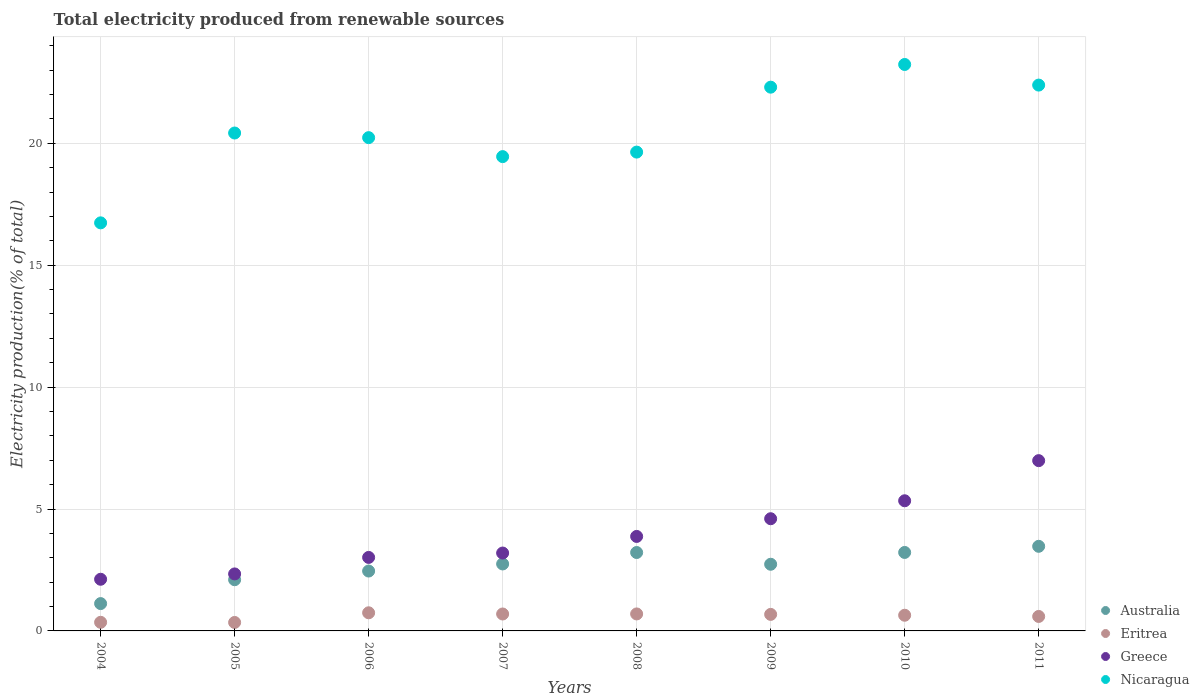Is the number of dotlines equal to the number of legend labels?
Your response must be concise. Yes. What is the total electricity produced in Nicaragua in 2004?
Provide a succinct answer. 16.74. Across all years, what is the maximum total electricity produced in Greece?
Give a very brief answer. 6.98. Across all years, what is the minimum total electricity produced in Greece?
Ensure brevity in your answer.  2.12. In which year was the total electricity produced in Australia minimum?
Provide a short and direct response. 2004. What is the total total electricity produced in Eritrea in the graph?
Ensure brevity in your answer.  4.75. What is the difference between the total electricity produced in Greece in 2006 and that in 2010?
Your answer should be very brief. -2.32. What is the difference between the total electricity produced in Australia in 2006 and the total electricity produced in Greece in 2005?
Give a very brief answer. 0.12. What is the average total electricity produced in Eritrea per year?
Offer a very short reply. 0.59. In the year 2010, what is the difference between the total electricity produced in Eritrea and total electricity produced in Greece?
Your answer should be compact. -4.69. In how many years, is the total electricity produced in Australia greater than 9 %?
Give a very brief answer. 0. What is the ratio of the total electricity produced in Greece in 2005 to that in 2006?
Make the answer very short. 0.78. What is the difference between the highest and the second highest total electricity produced in Australia?
Your answer should be compact. 0.25. What is the difference between the highest and the lowest total electricity produced in Eritrea?
Your answer should be very brief. 0.4. Is it the case that in every year, the sum of the total electricity produced in Nicaragua and total electricity produced in Eritrea  is greater than the total electricity produced in Australia?
Your answer should be very brief. Yes. Does the total electricity produced in Australia monotonically increase over the years?
Provide a short and direct response. No. How many dotlines are there?
Provide a succinct answer. 4. Does the graph contain any zero values?
Your response must be concise. No. How are the legend labels stacked?
Your response must be concise. Vertical. What is the title of the graph?
Your answer should be compact. Total electricity produced from renewable sources. What is the label or title of the Y-axis?
Provide a succinct answer. Electricity production(% of total). What is the Electricity production(% of total) in Australia in 2004?
Offer a terse response. 1.12. What is the Electricity production(% of total) in Eritrea in 2004?
Offer a terse response. 0.35. What is the Electricity production(% of total) of Greece in 2004?
Ensure brevity in your answer.  2.12. What is the Electricity production(% of total) in Nicaragua in 2004?
Provide a succinct answer. 16.74. What is the Electricity production(% of total) of Australia in 2005?
Keep it short and to the point. 2.1. What is the Electricity production(% of total) of Eritrea in 2005?
Offer a very short reply. 0.35. What is the Electricity production(% of total) of Greece in 2005?
Offer a terse response. 2.34. What is the Electricity production(% of total) in Nicaragua in 2005?
Your answer should be very brief. 20.42. What is the Electricity production(% of total) of Australia in 2006?
Your answer should be compact. 2.46. What is the Electricity production(% of total) of Eritrea in 2006?
Keep it short and to the point. 0.74. What is the Electricity production(% of total) of Greece in 2006?
Provide a short and direct response. 3.01. What is the Electricity production(% of total) in Nicaragua in 2006?
Offer a very short reply. 20.23. What is the Electricity production(% of total) of Australia in 2007?
Ensure brevity in your answer.  2.75. What is the Electricity production(% of total) of Eritrea in 2007?
Your answer should be very brief. 0.69. What is the Electricity production(% of total) of Greece in 2007?
Provide a succinct answer. 3.19. What is the Electricity production(% of total) in Nicaragua in 2007?
Provide a succinct answer. 19.45. What is the Electricity production(% of total) in Australia in 2008?
Offer a terse response. 3.22. What is the Electricity production(% of total) of Eritrea in 2008?
Provide a short and direct response. 0.7. What is the Electricity production(% of total) of Greece in 2008?
Ensure brevity in your answer.  3.88. What is the Electricity production(% of total) in Nicaragua in 2008?
Make the answer very short. 19.64. What is the Electricity production(% of total) of Australia in 2009?
Offer a very short reply. 2.73. What is the Electricity production(% of total) of Eritrea in 2009?
Give a very brief answer. 0.68. What is the Electricity production(% of total) in Greece in 2009?
Ensure brevity in your answer.  4.6. What is the Electricity production(% of total) in Nicaragua in 2009?
Make the answer very short. 22.3. What is the Electricity production(% of total) of Australia in 2010?
Make the answer very short. 3.22. What is the Electricity production(% of total) of Eritrea in 2010?
Your response must be concise. 0.64. What is the Electricity production(% of total) in Greece in 2010?
Give a very brief answer. 5.34. What is the Electricity production(% of total) of Nicaragua in 2010?
Offer a terse response. 23.23. What is the Electricity production(% of total) in Australia in 2011?
Provide a succinct answer. 3.47. What is the Electricity production(% of total) of Eritrea in 2011?
Offer a very short reply. 0.59. What is the Electricity production(% of total) of Greece in 2011?
Your answer should be very brief. 6.98. What is the Electricity production(% of total) in Nicaragua in 2011?
Offer a terse response. 22.38. Across all years, what is the maximum Electricity production(% of total) of Australia?
Provide a succinct answer. 3.47. Across all years, what is the maximum Electricity production(% of total) in Eritrea?
Your answer should be compact. 0.74. Across all years, what is the maximum Electricity production(% of total) in Greece?
Your response must be concise. 6.98. Across all years, what is the maximum Electricity production(% of total) of Nicaragua?
Provide a succinct answer. 23.23. Across all years, what is the minimum Electricity production(% of total) in Australia?
Keep it short and to the point. 1.12. Across all years, what is the minimum Electricity production(% of total) in Eritrea?
Your response must be concise. 0.35. Across all years, what is the minimum Electricity production(% of total) in Greece?
Give a very brief answer. 2.12. Across all years, what is the minimum Electricity production(% of total) in Nicaragua?
Make the answer very short. 16.74. What is the total Electricity production(% of total) of Australia in the graph?
Offer a terse response. 21.06. What is the total Electricity production(% of total) of Eritrea in the graph?
Make the answer very short. 4.75. What is the total Electricity production(% of total) in Greece in the graph?
Provide a short and direct response. 31.46. What is the total Electricity production(% of total) of Nicaragua in the graph?
Make the answer very short. 164.39. What is the difference between the Electricity production(% of total) of Australia in 2004 and that in 2005?
Your response must be concise. -0.98. What is the difference between the Electricity production(% of total) of Eritrea in 2004 and that in 2005?
Make the answer very short. 0.01. What is the difference between the Electricity production(% of total) in Greece in 2004 and that in 2005?
Your response must be concise. -0.22. What is the difference between the Electricity production(% of total) of Nicaragua in 2004 and that in 2005?
Provide a short and direct response. -3.68. What is the difference between the Electricity production(% of total) in Australia in 2004 and that in 2006?
Your answer should be very brief. -1.33. What is the difference between the Electricity production(% of total) of Eritrea in 2004 and that in 2006?
Your answer should be very brief. -0.39. What is the difference between the Electricity production(% of total) of Greece in 2004 and that in 2006?
Your response must be concise. -0.9. What is the difference between the Electricity production(% of total) in Nicaragua in 2004 and that in 2006?
Provide a succinct answer. -3.49. What is the difference between the Electricity production(% of total) of Australia in 2004 and that in 2007?
Offer a terse response. -1.63. What is the difference between the Electricity production(% of total) of Eritrea in 2004 and that in 2007?
Give a very brief answer. -0.34. What is the difference between the Electricity production(% of total) of Greece in 2004 and that in 2007?
Give a very brief answer. -1.08. What is the difference between the Electricity production(% of total) in Nicaragua in 2004 and that in 2007?
Offer a terse response. -2.72. What is the difference between the Electricity production(% of total) of Australia in 2004 and that in 2008?
Keep it short and to the point. -2.09. What is the difference between the Electricity production(% of total) of Eritrea in 2004 and that in 2008?
Your response must be concise. -0.34. What is the difference between the Electricity production(% of total) of Greece in 2004 and that in 2008?
Give a very brief answer. -1.76. What is the difference between the Electricity production(% of total) in Nicaragua in 2004 and that in 2008?
Offer a terse response. -2.9. What is the difference between the Electricity production(% of total) in Australia in 2004 and that in 2009?
Make the answer very short. -1.61. What is the difference between the Electricity production(% of total) in Eritrea in 2004 and that in 2009?
Keep it short and to the point. -0.32. What is the difference between the Electricity production(% of total) in Greece in 2004 and that in 2009?
Your answer should be compact. -2.48. What is the difference between the Electricity production(% of total) in Nicaragua in 2004 and that in 2009?
Your answer should be very brief. -5.56. What is the difference between the Electricity production(% of total) in Australia in 2004 and that in 2010?
Offer a terse response. -2.1. What is the difference between the Electricity production(% of total) in Eritrea in 2004 and that in 2010?
Provide a short and direct response. -0.29. What is the difference between the Electricity production(% of total) in Greece in 2004 and that in 2010?
Keep it short and to the point. -3.22. What is the difference between the Electricity production(% of total) in Nicaragua in 2004 and that in 2010?
Offer a terse response. -6.5. What is the difference between the Electricity production(% of total) in Australia in 2004 and that in 2011?
Provide a succinct answer. -2.35. What is the difference between the Electricity production(% of total) in Eritrea in 2004 and that in 2011?
Your answer should be very brief. -0.24. What is the difference between the Electricity production(% of total) of Greece in 2004 and that in 2011?
Offer a terse response. -4.86. What is the difference between the Electricity production(% of total) of Nicaragua in 2004 and that in 2011?
Keep it short and to the point. -5.65. What is the difference between the Electricity production(% of total) in Australia in 2005 and that in 2006?
Your answer should be compact. -0.36. What is the difference between the Electricity production(% of total) in Eritrea in 2005 and that in 2006?
Make the answer very short. -0.4. What is the difference between the Electricity production(% of total) of Greece in 2005 and that in 2006?
Offer a very short reply. -0.68. What is the difference between the Electricity production(% of total) in Nicaragua in 2005 and that in 2006?
Provide a short and direct response. 0.19. What is the difference between the Electricity production(% of total) of Australia in 2005 and that in 2007?
Provide a short and direct response. -0.65. What is the difference between the Electricity production(% of total) of Eritrea in 2005 and that in 2007?
Give a very brief answer. -0.35. What is the difference between the Electricity production(% of total) in Greece in 2005 and that in 2007?
Your answer should be very brief. -0.86. What is the difference between the Electricity production(% of total) of Nicaragua in 2005 and that in 2007?
Make the answer very short. 0.97. What is the difference between the Electricity production(% of total) in Australia in 2005 and that in 2008?
Offer a terse response. -1.12. What is the difference between the Electricity production(% of total) of Eritrea in 2005 and that in 2008?
Provide a short and direct response. -0.35. What is the difference between the Electricity production(% of total) in Greece in 2005 and that in 2008?
Provide a succinct answer. -1.54. What is the difference between the Electricity production(% of total) in Nicaragua in 2005 and that in 2008?
Provide a succinct answer. 0.78. What is the difference between the Electricity production(% of total) in Australia in 2005 and that in 2009?
Give a very brief answer. -0.63. What is the difference between the Electricity production(% of total) of Eritrea in 2005 and that in 2009?
Provide a short and direct response. -0.33. What is the difference between the Electricity production(% of total) in Greece in 2005 and that in 2009?
Your answer should be compact. -2.26. What is the difference between the Electricity production(% of total) in Nicaragua in 2005 and that in 2009?
Ensure brevity in your answer.  -1.88. What is the difference between the Electricity production(% of total) in Australia in 2005 and that in 2010?
Offer a terse response. -1.12. What is the difference between the Electricity production(% of total) in Eritrea in 2005 and that in 2010?
Make the answer very short. -0.3. What is the difference between the Electricity production(% of total) of Greece in 2005 and that in 2010?
Your response must be concise. -3. What is the difference between the Electricity production(% of total) of Nicaragua in 2005 and that in 2010?
Your response must be concise. -2.81. What is the difference between the Electricity production(% of total) in Australia in 2005 and that in 2011?
Make the answer very short. -1.37. What is the difference between the Electricity production(% of total) in Eritrea in 2005 and that in 2011?
Your response must be concise. -0.25. What is the difference between the Electricity production(% of total) of Greece in 2005 and that in 2011?
Your response must be concise. -4.65. What is the difference between the Electricity production(% of total) of Nicaragua in 2005 and that in 2011?
Make the answer very short. -1.97. What is the difference between the Electricity production(% of total) in Australia in 2006 and that in 2007?
Make the answer very short. -0.29. What is the difference between the Electricity production(% of total) of Eritrea in 2006 and that in 2007?
Keep it short and to the point. 0.05. What is the difference between the Electricity production(% of total) in Greece in 2006 and that in 2007?
Make the answer very short. -0.18. What is the difference between the Electricity production(% of total) of Nicaragua in 2006 and that in 2007?
Your answer should be compact. 0.78. What is the difference between the Electricity production(% of total) in Australia in 2006 and that in 2008?
Offer a very short reply. -0.76. What is the difference between the Electricity production(% of total) of Eritrea in 2006 and that in 2008?
Make the answer very short. 0.05. What is the difference between the Electricity production(% of total) in Greece in 2006 and that in 2008?
Your answer should be very brief. -0.86. What is the difference between the Electricity production(% of total) of Nicaragua in 2006 and that in 2008?
Offer a very short reply. 0.59. What is the difference between the Electricity production(% of total) in Australia in 2006 and that in 2009?
Make the answer very short. -0.28. What is the difference between the Electricity production(% of total) of Eritrea in 2006 and that in 2009?
Keep it short and to the point. 0.07. What is the difference between the Electricity production(% of total) of Greece in 2006 and that in 2009?
Make the answer very short. -1.59. What is the difference between the Electricity production(% of total) in Nicaragua in 2006 and that in 2009?
Make the answer very short. -2.07. What is the difference between the Electricity production(% of total) of Australia in 2006 and that in 2010?
Keep it short and to the point. -0.76. What is the difference between the Electricity production(% of total) of Eritrea in 2006 and that in 2010?
Make the answer very short. 0.1. What is the difference between the Electricity production(% of total) of Greece in 2006 and that in 2010?
Provide a succinct answer. -2.32. What is the difference between the Electricity production(% of total) in Nicaragua in 2006 and that in 2010?
Give a very brief answer. -3. What is the difference between the Electricity production(% of total) in Australia in 2006 and that in 2011?
Your answer should be very brief. -1.01. What is the difference between the Electricity production(% of total) in Eritrea in 2006 and that in 2011?
Offer a terse response. 0.15. What is the difference between the Electricity production(% of total) in Greece in 2006 and that in 2011?
Your answer should be compact. -3.97. What is the difference between the Electricity production(% of total) of Nicaragua in 2006 and that in 2011?
Your answer should be very brief. -2.16. What is the difference between the Electricity production(% of total) in Australia in 2007 and that in 2008?
Your answer should be very brief. -0.47. What is the difference between the Electricity production(% of total) of Eritrea in 2007 and that in 2008?
Your answer should be compact. -0. What is the difference between the Electricity production(% of total) of Greece in 2007 and that in 2008?
Offer a very short reply. -0.68. What is the difference between the Electricity production(% of total) in Nicaragua in 2007 and that in 2008?
Your answer should be compact. -0.19. What is the difference between the Electricity production(% of total) in Australia in 2007 and that in 2009?
Provide a short and direct response. 0.01. What is the difference between the Electricity production(% of total) of Eritrea in 2007 and that in 2009?
Give a very brief answer. 0.02. What is the difference between the Electricity production(% of total) in Greece in 2007 and that in 2009?
Provide a succinct answer. -1.41. What is the difference between the Electricity production(% of total) of Nicaragua in 2007 and that in 2009?
Your answer should be very brief. -2.85. What is the difference between the Electricity production(% of total) of Australia in 2007 and that in 2010?
Your response must be concise. -0.47. What is the difference between the Electricity production(% of total) of Eritrea in 2007 and that in 2010?
Provide a short and direct response. 0.05. What is the difference between the Electricity production(% of total) in Greece in 2007 and that in 2010?
Provide a succinct answer. -2.14. What is the difference between the Electricity production(% of total) in Nicaragua in 2007 and that in 2010?
Provide a short and direct response. -3.78. What is the difference between the Electricity production(% of total) of Australia in 2007 and that in 2011?
Give a very brief answer. -0.72. What is the difference between the Electricity production(% of total) in Eritrea in 2007 and that in 2011?
Offer a very short reply. 0.1. What is the difference between the Electricity production(% of total) in Greece in 2007 and that in 2011?
Ensure brevity in your answer.  -3.79. What is the difference between the Electricity production(% of total) of Nicaragua in 2007 and that in 2011?
Give a very brief answer. -2.93. What is the difference between the Electricity production(% of total) in Australia in 2008 and that in 2009?
Offer a very short reply. 0.48. What is the difference between the Electricity production(% of total) of Eritrea in 2008 and that in 2009?
Your answer should be compact. 0.02. What is the difference between the Electricity production(% of total) of Greece in 2008 and that in 2009?
Provide a short and direct response. -0.73. What is the difference between the Electricity production(% of total) of Nicaragua in 2008 and that in 2009?
Offer a terse response. -2.66. What is the difference between the Electricity production(% of total) in Australia in 2008 and that in 2010?
Ensure brevity in your answer.  -0. What is the difference between the Electricity production(% of total) of Eritrea in 2008 and that in 2010?
Your answer should be very brief. 0.05. What is the difference between the Electricity production(% of total) in Greece in 2008 and that in 2010?
Your response must be concise. -1.46. What is the difference between the Electricity production(% of total) in Nicaragua in 2008 and that in 2010?
Your answer should be compact. -3.59. What is the difference between the Electricity production(% of total) in Australia in 2008 and that in 2011?
Ensure brevity in your answer.  -0.25. What is the difference between the Electricity production(% of total) in Eritrea in 2008 and that in 2011?
Make the answer very short. 0.1. What is the difference between the Electricity production(% of total) of Greece in 2008 and that in 2011?
Your answer should be compact. -3.11. What is the difference between the Electricity production(% of total) in Nicaragua in 2008 and that in 2011?
Ensure brevity in your answer.  -2.75. What is the difference between the Electricity production(% of total) in Australia in 2009 and that in 2010?
Give a very brief answer. -0.48. What is the difference between the Electricity production(% of total) in Eritrea in 2009 and that in 2010?
Keep it short and to the point. 0.03. What is the difference between the Electricity production(% of total) in Greece in 2009 and that in 2010?
Ensure brevity in your answer.  -0.74. What is the difference between the Electricity production(% of total) of Nicaragua in 2009 and that in 2010?
Keep it short and to the point. -0.93. What is the difference between the Electricity production(% of total) of Australia in 2009 and that in 2011?
Your answer should be very brief. -0.74. What is the difference between the Electricity production(% of total) in Eritrea in 2009 and that in 2011?
Keep it short and to the point. 0.08. What is the difference between the Electricity production(% of total) of Greece in 2009 and that in 2011?
Ensure brevity in your answer.  -2.38. What is the difference between the Electricity production(% of total) in Nicaragua in 2009 and that in 2011?
Give a very brief answer. -0.09. What is the difference between the Electricity production(% of total) in Australia in 2010 and that in 2011?
Provide a short and direct response. -0.25. What is the difference between the Electricity production(% of total) in Eritrea in 2010 and that in 2011?
Give a very brief answer. 0.05. What is the difference between the Electricity production(% of total) of Greece in 2010 and that in 2011?
Your answer should be very brief. -1.65. What is the difference between the Electricity production(% of total) of Nicaragua in 2010 and that in 2011?
Provide a short and direct response. 0.85. What is the difference between the Electricity production(% of total) of Australia in 2004 and the Electricity production(% of total) of Eritrea in 2005?
Offer a terse response. 0.77. What is the difference between the Electricity production(% of total) in Australia in 2004 and the Electricity production(% of total) in Greece in 2005?
Provide a succinct answer. -1.22. What is the difference between the Electricity production(% of total) of Australia in 2004 and the Electricity production(% of total) of Nicaragua in 2005?
Give a very brief answer. -19.3. What is the difference between the Electricity production(% of total) in Eritrea in 2004 and the Electricity production(% of total) in Greece in 2005?
Your answer should be very brief. -1.98. What is the difference between the Electricity production(% of total) in Eritrea in 2004 and the Electricity production(% of total) in Nicaragua in 2005?
Your answer should be compact. -20.07. What is the difference between the Electricity production(% of total) in Greece in 2004 and the Electricity production(% of total) in Nicaragua in 2005?
Offer a terse response. -18.3. What is the difference between the Electricity production(% of total) in Australia in 2004 and the Electricity production(% of total) in Eritrea in 2006?
Ensure brevity in your answer.  0.38. What is the difference between the Electricity production(% of total) in Australia in 2004 and the Electricity production(% of total) in Greece in 2006?
Your answer should be compact. -1.89. What is the difference between the Electricity production(% of total) of Australia in 2004 and the Electricity production(% of total) of Nicaragua in 2006?
Your answer should be compact. -19.11. What is the difference between the Electricity production(% of total) of Eritrea in 2004 and the Electricity production(% of total) of Greece in 2006?
Your answer should be compact. -2.66. What is the difference between the Electricity production(% of total) in Eritrea in 2004 and the Electricity production(% of total) in Nicaragua in 2006?
Ensure brevity in your answer.  -19.88. What is the difference between the Electricity production(% of total) in Greece in 2004 and the Electricity production(% of total) in Nicaragua in 2006?
Your response must be concise. -18.11. What is the difference between the Electricity production(% of total) in Australia in 2004 and the Electricity production(% of total) in Eritrea in 2007?
Offer a very short reply. 0.43. What is the difference between the Electricity production(% of total) in Australia in 2004 and the Electricity production(% of total) in Greece in 2007?
Keep it short and to the point. -2.07. What is the difference between the Electricity production(% of total) of Australia in 2004 and the Electricity production(% of total) of Nicaragua in 2007?
Your answer should be very brief. -18.33. What is the difference between the Electricity production(% of total) in Eritrea in 2004 and the Electricity production(% of total) in Greece in 2007?
Offer a very short reply. -2.84. What is the difference between the Electricity production(% of total) in Eritrea in 2004 and the Electricity production(% of total) in Nicaragua in 2007?
Ensure brevity in your answer.  -19.1. What is the difference between the Electricity production(% of total) of Greece in 2004 and the Electricity production(% of total) of Nicaragua in 2007?
Provide a succinct answer. -17.33. What is the difference between the Electricity production(% of total) of Australia in 2004 and the Electricity production(% of total) of Eritrea in 2008?
Your response must be concise. 0.42. What is the difference between the Electricity production(% of total) in Australia in 2004 and the Electricity production(% of total) in Greece in 2008?
Your answer should be compact. -2.75. What is the difference between the Electricity production(% of total) in Australia in 2004 and the Electricity production(% of total) in Nicaragua in 2008?
Provide a succinct answer. -18.52. What is the difference between the Electricity production(% of total) in Eritrea in 2004 and the Electricity production(% of total) in Greece in 2008?
Give a very brief answer. -3.52. What is the difference between the Electricity production(% of total) of Eritrea in 2004 and the Electricity production(% of total) of Nicaragua in 2008?
Give a very brief answer. -19.28. What is the difference between the Electricity production(% of total) of Greece in 2004 and the Electricity production(% of total) of Nicaragua in 2008?
Keep it short and to the point. -17.52. What is the difference between the Electricity production(% of total) of Australia in 2004 and the Electricity production(% of total) of Eritrea in 2009?
Provide a short and direct response. 0.44. What is the difference between the Electricity production(% of total) in Australia in 2004 and the Electricity production(% of total) in Greece in 2009?
Offer a terse response. -3.48. What is the difference between the Electricity production(% of total) of Australia in 2004 and the Electricity production(% of total) of Nicaragua in 2009?
Your response must be concise. -21.18. What is the difference between the Electricity production(% of total) in Eritrea in 2004 and the Electricity production(% of total) in Greece in 2009?
Make the answer very short. -4.25. What is the difference between the Electricity production(% of total) of Eritrea in 2004 and the Electricity production(% of total) of Nicaragua in 2009?
Keep it short and to the point. -21.95. What is the difference between the Electricity production(% of total) of Greece in 2004 and the Electricity production(% of total) of Nicaragua in 2009?
Ensure brevity in your answer.  -20.18. What is the difference between the Electricity production(% of total) of Australia in 2004 and the Electricity production(% of total) of Eritrea in 2010?
Your response must be concise. 0.48. What is the difference between the Electricity production(% of total) of Australia in 2004 and the Electricity production(% of total) of Greece in 2010?
Ensure brevity in your answer.  -4.22. What is the difference between the Electricity production(% of total) in Australia in 2004 and the Electricity production(% of total) in Nicaragua in 2010?
Offer a terse response. -22.11. What is the difference between the Electricity production(% of total) of Eritrea in 2004 and the Electricity production(% of total) of Greece in 2010?
Keep it short and to the point. -4.98. What is the difference between the Electricity production(% of total) of Eritrea in 2004 and the Electricity production(% of total) of Nicaragua in 2010?
Provide a succinct answer. -22.88. What is the difference between the Electricity production(% of total) of Greece in 2004 and the Electricity production(% of total) of Nicaragua in 2010?
Make the answer very short. -21.11. What is the difference between the Electricity production(% of total) of Australia in 2004 and the Electricity production(% of total) of Eritrea in 2011?
Offer a very short reply. 0.53. What is the difference between the Electricity production(% of total) of Australia in 2004 and the Electricity production(% of total) of Greece in 2011?
Your answer should be very brief. -5.86. What is the difference between the Electricity production(% of total) in Australia in 2004 and the Electricity production(% of total) in Nicaragua in 2011?
Make the answer very short. -21.26. What is the difference between the Electricity production(% of total) of Eritrea in 2004 and the Electricity production(% of total) of Greece in 2011?
Provide a short and direct response. -6.63. What is the difference between the Electricity production(% of total) in Eritrea in 2004 and the Electricity production(% of total) in Nicaragua in 2011?
Give a very brief answer. -22.03. What is the difference between the Electricity production(% of total) of Greece in 2004 and the Electricity production(% of total) of Nicaragua in 2011?
Ensure brevity in your answer.  -20.27. What is the difference between the Electricity production(% of total) of Australia in 2005 and the Electricity production(% of total) of Eritrea in 2006?
Offer a terse response. 1.36. What is the difference between the Electricity production(% of total) in Australia in 2005 and the Electricity production(% of total) in Greece in 2006?
Give a very brief answer. -0.91. What is the difference between the Electricity production(% of total) of Australia in 2005 and the Electricity production(% of total) of Nicaragua in 2006?
Your response must be concise. -18.13. What is the difference between the Electricity production(% of total) in Eritrea in 2005 and the Electricity production(% of total) in Greece in 2006?
Provide a short and direct response. -2.67. What is the difference between the Electricity production(% of total) in Eritrea in 2005 and the Electricity production(% of total) in Nicaragua in 2006?
Your answer should be compact. -19.88. What is the difference between the Electricity production(% of total) of Greece in 2005 and the Electricity production(% of total) of Nicaragua in 2006?
Keep it short and to the point. -17.89. What is the difference between the Electricity production(% of total) in Australia in 2005 and the Electricity production(% of total) in Eritrea in 2007?
Ensure brevity in your answer.  1.41. What is the difference between the Electricity production(% of total) of Australia in 2005 and the Electricity production(% of total) of Greece in 2007?
Your answer should be compact. -1.09. What is the difference between the Electricity production(% of total) of Australia in 2005 and the Electricity production(% of total) of Nicaragua in 2007?
Your response must be concise. -17.35. What is the difference between the Electricity production(% of total) of Eritrea in 2005 and the Electricity production(% of total) of Greece in 2007?
Your answer should be very brief. -2.85. What is the difference between the Electricity production(% of total) in Eritrea in 2005 and the Electricity production(% of total) in Nicaragua in 2007?
Provide a succinct answer. -19.1. What is the difference between the Electricity production(% of total) in Greece in 2005 and the Electricity production(% of total) in Nicaragua in 2007?
Give a very brief answer. -17.11. What is the difference between the Electricity production(% of total) of Australia in 2005 and the Electricity production(% of total) of Eritrea in 2008?
Provide a short and direct response. 1.4. What is the difference between the Electricity production(% of total) of Australia in 2005 and the Electricity production(% of total) of Greece in 2008?
Offer a terse response. -1.78. What is the difference between the Electricity production(% of total) of Australia in 2005 and the Electricity production(% of total) of Nicaragua in 2008?
Make the answer very short. -17.54. What is the difference between the Electricity production(% of total) in Eritrea in 2005 and the Electricity production(% of total) in Greece in 2008?
Your answer should be very brief. -3.53. What is the difference between the Electricity production(% of total) of Eritrea in 2005 and the Electricity production(% of total) of Nicaragua in 2008?
Your response must be concise. -19.29. What is the difference between the Electricity production(% of total) in Greece in 2005 and the Electricity production(% of total) in Nicaragua in 2008?
Your answer should be very brief. -17.3. What is the difference between the Electricity production(% of total) in Australia in 2005 and the Electricity production(% of total) in Eritrea in 2009?
Keep it short and to the point. 1.42. What is the difference between the Electricity production(% of total) of Australia in 2005 and the Electricity production(% of total) of Greece in 2009?
Keep it short and to the point. -2.5. What is the difference between the Electricity production(% of total) of Australia in 2005 and the Electricity production(% of total) of Nicaragua in 2009?
Give a very brief answer. -20.2. What is the difference between the Electricity production(% of total) in Eritrea in 2005 and the Electricity production(% of total) in Greece in 2009?
Your answer should be very brief. -4.25. What is the difference between the Electricity production(% of total) in Eritrea in 2005 and the Electricity production(% of total) in Nicaragua in 2009?
Keep it short and to the point. -21.95. What is the difference between the Electricity production(% of total) of Greece in 2005 and the Electricity production(% of total) of Nicaragua in 2009?
Provide a succinct answer. -19.96. What is the difference between the Electricity production(% of total) in Australia in 2005 and the Electricity production(% of total) in Eritrea in 2010?
Provide a short and direct response. 1.46. What is the difference between the Electricity production(% of total) in Australia in 2005 and the Electricity production(% of total) in Greece in 2010?
Your response must be concise. -3.24. What is the difference between the Electricity production(% of total) in Australia in 2005 and the Electricity production(% of total) in Nicaragua in 2010?
Offer a very short reply. -21.13. What is the difference between the Electricity production(% of total) in Eritrea in 2005 and the Electricity production(% of total) in Greece in 2010?
Give a very brief answer. -4.99. What is the difference between the Electricity production(% of total) of Eritrea in 2005 and the Electricity production(% of total) of Nicaragua in 2010?
Give a very brief answer. -22.88. What is the difference between the Electricity production(% of total) in Greece in 2005 and the Electricity production(% of total) in Nicaragua in 2010?
Your answer should be very brief. -20.89. What is the difference between the Electricity production(% of total) in Australia in 2005 and the Electricity production(% of total) in Eritrea in 2011?
Your answer should be very brief. 1.51. What is the difference between the Electricity production(% of total) in Australia in 2005 and the Electricity production(% of total) in Greece in 2011?
Keep it short and to the point. -4.88. What is the difference between the Electricity production(% of total) in Australia in 2005 and the Electricity production(% of total) in Nicaragua in 2011?
Your answer should be compact. -20.29. What is the difference between the Electricity production(% of total) of Eritrea in 2005 and the Electricity production(% of total) of Greece in 2011?
Make the answer very short. -6.64. What is the difference between the Electricity production(% of total) of Eritrea in 2005 and the Electricity production(% of total) of Nicaragua in 2011?
Ensure brevity in your answer.  -22.04. What is the difference between the Electricity production(% of total) in Greece in 2005 and the Electricity production(% of total) in Nicaragua in 2011?
Your response must be concise. -20.05. What is the difference between the Electricity production(% of total) in Australia in 2006 and the Electricity production(% of total) in Eritrea in 2007?
Ensure brevity in your answer.  1.76. What is the difference between the Electricity production(% of total) in Australia in 2006 and the Electricity production(% of total) in Greece in 2007?
Give a very brief answer. -0.74. What is the difference between the Electricity production(% of total) in Australia in 2006 and the Electricity production(% of total) in Nicaragua in 2007?
Keep it short and to the point. -17. What is the difference between the Electricity production(% of total) of Eritrea in 2006 and the Electricity production(% of total) of Greece in 2007?
Offer a terse response. -2.45. What is the difference between the Electricity production(% of total) of Eritrea in 2006 and the Electricity production(% of total) of Nicaragua in 2007?
Give a very brief answer. -18.71. What is the difference between the Electricity production(% of total) in Greece in 2006 and the Electricity production(% of total) in Nicaragua in 2007?
Offer a very short reply. -16.44. What is the difference between the Electricity production(% of total) in Australia in 2006 and the Electricity production(% of total) in Eritrea in 2008?
Make the answer very short. 1.76. What is the difference between the Electricity production(% of total) in Australia in 2006 and the Electricity production(% of total) in Greece in 2008?
Provide a short and direct response. -1.42. What is the difference between the Electricity production(% of total) of Australia in 2006 and the Electricity production(% of total) of Nicaragua in 2008?
Make the answer very short. -17.18. What is the difference between the Electricity production(% of total) in Eritrea in 2006 and the Electricity production(% of total) in Greece in 2008?
Your response must be concise. -3.13. What is the difference between the Electricity production(% of total) of Eritrea in 2006 and the Electricity production(% of total) of Nicaragua in 2008?
Give a very brief answer. -18.89. What is the difference between the Electricity production(% of total) of Greece in 2006 and the Electricity production(% of total) of Nicaragua in 2008?
Offer a terse response. -16.62. What is the difference between the Electricity production(% of total) in Australia in 2006 and the Electricity production(% of total) in Eritrea in 2009?
Offer a very short reply. 1.78. What is the difference between the Electricity production(% of total) of Australia in 2006 and the Electricity production(% of total) of Greece in 2009?
Ensure brevity in your answer.  -2.15. What is the difference between the Electricity production(% of total) in Australia in 2006 and the Electricity production(% of total) in Nicaragua in 2009?
Your response must be concise. -19.84. What is the difference between the Electricity production(% of total) of Eritrea in 2006 and the Electricity production(% of total) of Greece in 2009?
Your response must be concise. -3.86. What is the difference between the Electricity production(% of total) in Eritrea in 2006 and the Electricity production(% of total) in Nicaragua in 2009?
Your answer should be compact. -21.56. What is the difference between the Electricity production(% of total) of Greece in 2006 and the Electricity production(% of total) of Nicaragua in 2009?
Make the answer very short. -19.29. What is the difference between the Electricity production(% of total) of Australia in 2006 and the Electricity production(% of total) of Eritrea in 2010?
Your answer should be compact. 1.81. What is the difference between the Electricity production(% of total) of Australia in 2006 and the Electricity production(% of total) of Greece in 2010?
Make the answer very short. -2.88. What is the difference between the Electricity production(% of total) in Australia in 2006 and the Electricity production(% of total) in Nicaragua in 2010?
Your response must be concise. -20.77. What is the difference between the Electricity production(% of total) in Eritrea in 2006 and the Electricity production(% of total) in Greece in 2010?
Keep it short and to the point. -4.59. What is the difference between the Electricity production(% of total) in Eritrea in 2006 and the Electricity production(% of total) in Nicaragua in 2010?
Your response must be concise. -22.49. What is the difference between the Electricity production(% of total) of Greece in 2006 and the Electricity production(% of total) of Nicaragua in 2010?
Your answer should be very brief. -20.22. What is the difference between the Electricity production(% of total) in Australia in 2006 and the Electricity production(% of total) in Eritrea in 2011?
Give a very brief answer. 1.86. What is the difference between the Electricity production(% of total) in Australia in 2006 and the Electricity production(% of total) in Greece in 2011?
Ensure brevity in your answer.  -4.53. What is the difference between the Electricity production(% of total) in Australia in 2006 and the Electricity production(% of total) in Nicaragua in 2011?
Your answer should be compact. -19.93. What is the difference between the Electricity production(% of total) in Eritrea in 2006 and the Electricity production(% of total) in Greece in 2011?
Keep it short and to the point. -6.24. What is the difference between the Electricity production(% of total) of Eritrea in 2006 and the Electricity production(% of total) of Nicaragua in 2011?
Your answer should be very brief. -21.64. What is the difference between the Electricity production(% of total) in Greece in 2006 and the Electricity production(% of total) in Nicaragua in 2011?
Your response must be concise. -19.37. What is the difference between the Electricity production(% of total) in Australia in 2007 and the Electricity production(% of total) in Eritrea in 2008?
Provide a succinct answer. 2.05. What is the difference between the Electricity production(% of total) of Australia in 2007 and the Electricity production(% of total) of Greece in 2008?
Your answer should be compact. -1.13. What is the difference between the Electricity production(% of total) of Australia in 2007 and the Electricity production(% of total) of Nicaragua in 2008?
Offer a very short reply. -16.89. What is the difference between the Electricity production(% of total) of Eritrea in 2007 and the Electricity production(% of total) of Greece in 2008?
Offer a very short reply. -3.18. What is the difference between the Electricity production(% of total) of Eritrea in 2007 and the Electricity production(% of total) of Nicaragua in 2008?
Provide a short and direct response. -18.94. What is the difference between the Electricity production(% of total) of Greece in 2007 and the Electricity production(% of total) of Nicaragua in 2008?
Provide a short and direct response. -16.44. What is the difference between the Electricity production(% of total) in Australia in 2007 and the Electricity production(% of total) in Eritrea in 2009?
Your answer should be very brief. 2.07. What is the difference between the Electricity production(% of total) of Australia in 2007 and the Electricity production(% of total) of Greece in 2009?
Your response must be concise. -1.85. What is the difference between the Electricity production(% of total) in Australia in 2007 and the Electricity production(% of total) in Nicaragua in 2009?
Offer a very short reply. -19.55. What is the difference between the Electricity production(% of total) in Eritrea in 2007 and the Electricity production(% of total) in Greece in 2009?
Your answer should be very brief. -3.91. What is the difference between the Electricity production(% of total) of Eritrea in 2007 and the Electricity production(% of total) of Nicaragua in 2009?
Provide a succinct answer. -21.61. What is the difference between the Electricity production(% of total) of Greece in 2007 and the Electricity production(% of total) of Nicaragua in 2009?
Your answer should be compact. -19.11. What is the difference between the Electricity production(% of total) of Australia in 2007 and the Electricity production(% of total) of Eritrea in 2010?
Offer a terse response. 2.1. What is the difference between the Electricity production(% of total) in Australia in 2007 and the Electricity production(% of total) in Greece in 2010?
Your answer should be very brief. -2.59. What is the difference between the Electricity production(% of total) of Australia in 2007 and the Electricity production(% of total) of Nicaragua in 2010?
Your answer should be very brief. -20.48. What is the difference between the Electricity production(% of total) of Eritrea in 2007 and the Electricity production(% of total) of Greece in 2010?
Ensure brevity in your answer.  -4.64. What is the difference between the Electricity production(% of total) of Eritrea in 2007 and the Electricity production(% of total) of Nicaragua in 2010?
Offer a very short reply. -22.54. What is the difference between the Electricity production(% of total) in Greece in 2007 and the Electricity production(% of total) in Nicaragua in 2010?
Make the answer very short. -20.04. What is the difference between the Electricity production(% of total) of Australia in 2007 and the Electricity production(% of total) of Eritrea in 2011?
Your answer should be compact. 2.15. What is the difference between the Electricity production(% of total) of Australia in 2007 and the Electricity production(% of total) of Greece in 2011?
Provide a succinct answer. -4.24. What is the difference between the Electricity production(% of total) of Australia in 2007 and the Electricity production(% of total) of Nicaragua in 2011?
Make the answer very short. -19.64. What is the difference between the Electricity production(% of total) of Eritrea in 2007 and the Electricity production(% of total) of Greece in 2011?
Your answer should be compact. -6.29. What is the difference between the Electricity production(% of total) in Eritrea in 2007 and the Electricity production(% of total) in Nicaragua in 2011?
Provide a short and direct response. -21.69. What is the difference between the Electricity production(% of total) of Greece in 2007 and the Electricity production(% of total) of Nicaragua in 2011?
Make the answer very short. -19.19. What is the difference between the Electricity production(% of total) of Australia in 2008 and the Electricity production(% of total) of Eritrea in 2009?
Ensure brevity in your answer.  2.54. What is the difference between the Electricity production(% of total) in Australia in 2008 and the Electricity production(% of total) in Greece in 2009?
Make the answer very short. -1.39. What is the difference between the Electricity production(% of total) in Australia in 2008 and the Electricity production(% of total) in Nicaragua in 2009?
Give a very brief answer. -19.08. What is the difference between the Electricity production(% of total) of Eritrea in 2008 and the Electricity production(% of total) of Greece in 2009?
Provide a succinct answer. -3.9. What is the difference between the Electricity production(% of total) in Eritrea in 2008 and the Electricity production(% of total) in Nicaragua in 2009?
Give a very brief answer. -21.6. What is the difference between the Electricity production(% of total) in Greece in 2008 and the Electricity production(% of total) in Nicaragua in 2009?
Ensure brevity in your answer.  -18.42. What is the difference between the Electricity production(% of total) in Australia in 2008 and the Electricity production(% of total) in Eritrea in 2010?
Make the answer very short. 2.57. What is the difference between the Electricity production(% of total) of Australia in 2008 and the Electricity production(% of total) of Greece in 2010?
Your answer should be compact. -2.12. What is the difference between the Electricity production(% of total) of Australia in 2008 and the Electricity production(% of total) of Nicaragua in 2010?
Make the answer very short. -20.01. What is the difference between the Electricity production(% of total) of Eritrea in 2008 and the Electricity production(% of total) of Greece in 2010?
Offer a very short reply. -4.64. What is the difference between the Electricity production(% of total) of Eritrea in 2008 and the Electricity production(% of total) of Nicaragua in 2010?
Your answer should be compact. -22.53. What is the difference between the Electricity production(% of total) in Greece in 2008 and the Electricity production(% of total) in Nicaragua in 2010?
Offer a terse response. -19.36. What is the difference between the Electricity production(% of total) of Australia in 2008 and the Electricity production(% of total) of Eritrea in 2011?
Offer a terse response. 2.62. What is the difference between the Electricity production(% of total) of Australia in 2008 and the Electricity production(% of total) of Greece in 2011?
Give a very brief answer. -3.77. What is the difference between the Electricity production(% of total) of Australia in 2008 and the Electricity production(% of total) of Nicaragua in 2011?
Your answer should be compact. -19.17. What is the difference between the Electricity production(% of total) in Eritrea in 2008 and the Electricity production(% of total) in Greece in 2011?
Offer a very short reply. -6.29. What is the difference between the Electricity production(% of total) in Eritrea in 2008 and the Electricity production(% of total) in Nicaragua in 2011?
Your response must be concise. -21.69. What is the difference between the Electricity production(% of total) in Greece in 2008 and the Electricity production(% of total) in Nicaragua in 2011?
Offer a terse response. -18.51. What is the difference between the Electricity production(% of total) of Australia in 2009 and the Electricity production(% of total) of Eritrea in 2010?
Make the answer very short. 2.09. What is the difference between the Electricity production(% of total) of Australia in 2009 and the Electricity production(% of total) of Greece in 2010?
Make the answer very short. -2.6. What is the difference between the Electricity production(% of total) in Australia in 2009 and the Electricity production(% of total) in Nicaragua in 2010?
Your answer should be very brief. -20.5. What is the difference between the Electricity production(% of total) in Eritrea in 2009 and the Electricity production(% of total) in Greece in 2010?
Your response must be concise. -4.66. What is the difference between the Electricity production(% of total) in Eritrea in 2009 and the Electricity production(% of total) in Nicaragua in 2010?
Your answer should be compact. -22.55. What is the difference between the Electricity production(% of total) of Greece in 2009 and the Electricity production(% of total) of Nicaragua in 2010?
Your response must be concise. -18.63. What is the difference between the Electricity production(% of total) of Australia in 2009 and the Electricity production(% of total) of Eritrea in 2011?
Your response must be concise. 2.14. What is the difference between the Electricity production(% of total) of Australia in 2009 and the Electricity production(% of total) of Greece in 2011?
Keep it short and to the point. -4.25. What is the difference between the Electricity production(% of total) in Australia in 2009 and the Electricity production(% of total) in Nicaragua in 2011?
Make the answer very short. -19.65. What is the difference between the Electricity production(% of total) of Eritrea in 2009 and the Electricity production(% of total) of Greece in 2011?
Provide a succinct answer. -6.31. What is the difference between the Electricity production(% of total) of Eritrea in 2009 and the Electricity production(% of total) of Nicaragua in 2011?
Your answer should be compact. -21.71. What is the difference between the Electricity production(% of total) in Greece in 2009 and the Electricity production(% of total) in Nicaragua in 2011?
Your response must be concise. -17.78. What is the difference between the Electricity production(% of total) of Australia in 2010 and the Electricity production(% of total) of Eritrea in 2011?
Your answer should be compact. 2.62. What is the difference between the Electricity production(% of total) in Australia in 2010 and the Electricity production(% of total) in Greece in 2011?
Provide a succinct answer. -3.77. What is the difference between the Electricity production(% of total) in Australia in 2010 and the Electricity production(% of total) in Nicaragua in 2011?
Make the answer very short. -19.17. What is the difference between the Electricity production(% of total) in Eritrea in 2010 and the Electricity production(% of total) in Greece in 2011?
Offer a terse response. -6.34. What is the difference between the Electricity production(% of total) of Eritrea in 2010 and the Electricity production(% of total) of Nicaragua in 2011?
Keep it short and to the point. -21.74. What is the difference between the Electricity production(% of total) of Greece in 2010 and the Electricity production(% of total) of Nicaragua in 2011?
Offer a very short reply. -17.05. What is the average Electricity production(% of total) in Australia per year?
Your answer should be compact. 2.63. What is the average Electricity production(% of total) in Eritrea per year?
Ensure brevity in your answer.  0.59. What is the average Electricity production(% of total) in Greece per year?
Ensure brevity in your answer.  3.93. What is the average Electricity production(% of total) of Nicaragua per year?
Give a very brief answer. 20.55. In the year 2004, what is the difference between the Electricity production(% of total) of Australia and Electricity production(% of total) of Eritrea?
Provide a succinct answer. 0.77. In the year 2004, what is the difference between the Electricity production(% of total) in Australia and Electricity production(% of total) in Greece?
Keep it short and to the point. -1. In the year 2004, what is the difference between the Electricity production(% of total) in Australia and Electricity production(% of total) in Nicaragua?
Ensure brevity in your answer.  -15.61. In the year 2004, what is the difference between the Electricity production(% of total) of Eritrea and Electricity production(% of total) of Greece?
Give a very brief answer. -1.77. In the year 2004, what is the difference between the Electricity production(% of total) in Eritrea and Electricity production(% of total) in Nicaragua?
Your response must be concise. -16.38. In the year 2004, what is the difference between the Electricity production(% of total) in Greece and Electricity production(% of total) in Nicaragua?
Make the answer very short. -14.62. In the year 2005, what is the difference between the Electricity production(% of total) in Australia and Electricity production(% of total) in Eritrea?
Offer a terse response. 1.75. In the year 2005, what is the difference between the Electricity production(% of total) in Australia and Electricity production(% of total) in Greece?
Keep it short and to the point. -0.24. In the year 2005, what is the difference between the Electricity production(% of total) in Australia and Electricity production(% of total) in Nicaragua?
Your answer should be very brief. -18.32. In the year 2005, what is the difference between the Electricity production(% of total) of Eritrea and Electricity production(% of total) of Greece?
Provide a short and direct response. -1.99. In the year 2005, what is the difference between the Electricity production(% of total) in Eritrea and Electricity production(% of total) in Nicaragua?
Your answer should be compact. -20.07. In the year 2005, what is the difference between the Electricity production(% of total) in Greece and Electricity production(% of total) in Nicaragua?
Give a very brief answer. -18.08. In the year 2006, what is the difference between the Electricity production(% of total) of Australia and Electricity production(% of total) of Eritrea?
Make the answer very short. 1.71. In the year 2006, what is the difference between the Electricity production(% of total) in Australia and Electricity production(% of total) in Greece?
Provide a short and direct response. -0.56. In the year 2006, what is the difference between the Electricity production(% of total) of Australia and Electricity production(% of total) of Nicaragua?
Your answer should be compact. -17.77. In the year 2006, what is the difference between the Electricity production(% of total) in Eritrea and Electricity production(% of total) in Greece?
Your response must be concise. -2.27. In the year 2006, what is the difference between the Electricity production(% of total) of Eritrea and Electricity production(% of total) of Nicaragua?
Provide a succinct answer. -19.49. In the year 2006, what is the difference between the Electricity production(% of total) in Greece and Electricity production(% of total) in Nicaragua?
Provide a succinct answer. -17.22. In the year 2007, what is the difference between the Electricity production(% of total) in Australia and Electricity production(% of total) in Eritrea?
Make the answer very short. 2.05. In the year 2007, what is the difference between the Electricity production(% of total) in Australia and Electricity production(% of total) in Greece?
Make the answer very short. -0.45. In the year 2007, what is the difference between the Electricity production(% of total) of Australia and Electricity production(% of total) of Nicaragua?
Keep it short and to the point. -16.7. In the year 2007, what is the difference between the Electricity production(% of total) of Eritrea and Electricity production(% of total) of Greece?
Your answer should be very brief. -2.5. In the year 2007, what is the difference between the Electricity production(% of total) in Eritrea and Electricity production(% of total) in Nicaragua?
Make the answer very short. -18.76. In the year 2007, what is the difference between the Electricity production(% of total) of Greece and Electricity production(% of total) of Nicaragua?
Offer a terse response. -16.26. In the year 2008, what is the difference between the Electricity production(% of total) of Australia and Electricity production(% of total) of Eritrea?
Your answer should be compact. 2.52. In the year 2008, what is the difference between the Electricity production(% of total) in Australia and Electricity production(% of total) in Greece?
Your answer should be very brief. -0.66. In the year 2008, what is the difference between the Electricity production(% of total) in Australia and Electricity production(% of total) in Nicaragua?
Your answer should be very brief. -16.42. In the year 2008, what is the difference between the Electricity production(% of total) in Eritrea and Electricity production(% of total) in Greece?
Give a very brief answer. -3.18. In the year 2008, what is the difference between the Electricity production(% of total) in Eritrea and Electricity production(% of total) in Nicaragua?
Provide a short and direct response. -18.94. In the year 2008, what is the difference between the Electricity production(% of total) in Greece and Electricity production(% of total) in Nicaragua?
Ensure brevity in your answer.  -15.76. In the year 2009, what is the difference between the Electricity production(% of total) of Australia and Electricity production(% of total) of Eritrea?
Provide a short and direct response. 2.06. In the year 2009, what is the difference between the Electricity production(% of total) of Australia and Electricity production(% of total) of Greece?
Keep it short and to the point. -1.87. In the year 2009, what is the difference between the Electricity production(% of total) of Australia and Electricity production(% of total) of Nicaragua?
Keep it short and to the point. -19.57. In the year 2009, what is the difference between the Electricity production(% of total) of Eritrea and Electricity production(% of total) of Greece?
Provide a short and direct response. -3.92. In the year 2009, what is the difference between the Electricity production(% of total) of Eritrea and Electricity production(% of total) of Nicaragua?
Provide a succinct answer. -21.62. In the year 2009, what is the difference between the Electricity production(% of total) in Greece and Electricity production(% of total) in Nicaragua?
Your answer should be very brief. -17.7. In the year 2010, what is the difference between the Electricity production(% of total) of Australia and Electricity production(% of total) of Eritrea?
Provide a short and direct response. 2.58. In the year 2010, what is the difference between the Electricity production(% of total) in Australia and Electricity production(% of total) in Greece?
Ensure brevity in your answer.  -2.12. In the year 2010, what is the difference between the Electricity production(% of total) in Australia and Electricity production(% of total) in Nicaragua?
Offer a terse response. -20.01. In the year 2010, what is the difference between the Electricity production(% of total) of Eritrea and Electricity production(% of total) of Greece?
Your answer should be compact. -4.69. In the year 2010, what is the difference between the Electricity production(% of total) of Eritrea and Electricity production(% of total) of Nicaragua?
Your answer should be compact. -22.59. In the year 2010, what is the difference between the Electricity production(% of total) in Greece and Electricity production(% of total) in Nicaragua?
Keep it short and to the point. -17.89. In the year 2011, what is the difference between the Electricity production(% of total) in Australia and Electricity production(% of total) in Eritrea?
Your response must be concise. 2.88. In the year 2011, what is the difference between the Electricity production(% of total) in Australia and Electricity production(% of total) in Greece?
Your response must be concise. -3.51. In the year 2011, what is the difference between the Electricity production(% of total) of Australia and Electricity production(% of total) of Nicaragua?
Keep it short and to the point. -18.91. In the year 2011, what is the difference between the Electricity production(% of total) in Eritrea and Electricity production(% of total) in Greece?
Your answer should be very brief. -6.39. In the year 2011, what is the difference between the Electricity production(% of total) of Eritrea and Electricity production(% of total) of Nicaragua?
Offer a terse response. -21.79. In the year 2011, what is the difference between the Electricity production(% of total) of Greece and Electricity production(% of total) of Nicaragua?
Offer a very short reply. -15.4. What is the ratio of the Electricity production(% of total) in Australia in 2004 to that in 2005?
Make the answer very short. 0.53. What is the ratio of the Electricity production(% of total) of Eritrea in 2004 to that in 2005?
Ensure brevity in your answer.  1.02. What is the ratio of the Electricity production(% of total) of Greece in 2004 to that in 2005?
Make the answer very short. 0.91. What is the ratio of the Electricity production(% of total) of Nicaragua in 2004 to that in 2005?
Make the answer very short. 0.82. What is the ratio of the Electricity production(% of total) in Australia in 2004 to that in 2006?
Offer a very short reply. 0.46. What is the ratio of the Electricity production(% of total) in Eritrea in 2004 to that in 2006?
Keep it short and to the point. 0.48. What is the ratio of the Electricity production(% of total) in Greece in 2004 to that in 2006?
Your response must be concise. 0.7. What is the ratio of the Electricity production(% of total) in Nicaragua in 2004 to that in 2006?
Your answer should be compact. 0.83. What is the ratio of the Electricity production(% of total) in Australia in 2004 to that in 2007?
Your answer should be compact. 0.41. What is the ratio of the Electricity production(% of total) of Eritrea in 2004 to that in 2007?
Make the answer very short. 0.51. What is the ratio of the Electricity production(% of total) in Greece in 2004 to that in 2007?
Provide a short and direct response. 0.66. What is the ratio of the Electricity production(% of total) of Nicaragua in 2004 to that in 2007?
Your answer should be compact. 0.86. What is the ratio of the Electricity production(% of total) of Australia in 2004 to that in 2008?
Offer a very short reply. 0.35. What is the ratio of the Electricity production(% of total) in Eritrea in 2004 to that in 2008?
Provide a short and direct response. 0.51. What is the ratio of the Electricity production(% of total) in Greece in 2004 to that in 2008?
Offer a terse response. 0.55. What is the ratio of the Electricity production(% of total) in Nicaragua in 2004 to that in 2008?
Offer a very short reply. 0.85. What is the ratio of the Electricity production(% of total) of Australia in 2004 to that in 2009?
Make the answer very short. 0.41. What is the ratio of the Electricity production(% of total) of Eritrea in 2004 to that in 2009?
Offer a very short reply. 0.52. What is the ratio of the Electricity production(% of total) in Greece in 2004 to that in 2009?
Offer a terse response. 0.46. What is the ratio of the Electricity production(% of total) in Nicaragua in 2004 to that in 2009?
Provide a short and direct response. 0.75. What is the ratio of the Electricity production(% of total) in Australia in 2004 to that in 2010?
Provide a succinct answer. 0.35. What is the ratio of the Electricity production(% of total) in Eritrea in 2004 to that in 2010?
Keep it short and to the point. 0.55. What is the ratio of the Electricity production(% of total) of Greece in 2004 to that in 2010?
Offer a very short reply. 0.4. What is the ratio of the Electricity production(% of total) of Nicaragua in 2004 to that in 2010?
Provide a short and direct response. 0.72. What is the ratio of the Electricity production(% of total) of Australia in 2004 to that in 2011?
Your answer should be very brief. 0.32. What is the ratio of the Electricity production(% of total) in Eritrea in 2004 to that in 2011?
Keep it short and to the point. 0.6. What is the ratio of the Electricity production(% of total) of Greece in 2004 to that in 2011?
Provide a succinct answer. 0.3. What is the ratio of the Electricity production(% of total) of Nicaragua in 2004 to that in 2011?
Keep it short and to the point. 0.75. What is the ratio of the Electricity production(% of total) of Australia in 2005 to that in 2006?
Keep it short and to the point. 0.85. What is the ratio of the Electricity production(% of total) in Eritrea in 2005 to that in 2006?
Make the answer very short. 0.47. What is the ratio of the Electricity production(% of total) of Greece in 2005 to that in 2006?
Give a very brief answer. 0.78. What is the ratio of the Electricity production(% of total) of Nicaragua in 2005 to that in 2006?
Give a very brief answer. 1.01. What is the ratio of the Electricity production(% of total) of Australia in 2005 to that in 2007?
Ensure brevity in your answer.  0.76. What is the ratio of the Electricity production(% of total) in Greece in 2005 to that in 2007?
Your answer should be compact. 0.73. What is the ratio of the Electricity production(% of total) in Nicaragua in 2005 to that in 2007?
Ensure brevity in your answer.  1.05. What is the ratio of the Electricity production(% of total) in Australia in 2005 to that in 2008?
Your response must be concise. 0.65. What is the ratio of the Electricity production(% of total) of Eritrea in 2005 to that in 2008?
Your answer should be compact. 0.5. What is the ratio of the Electricity production(% of total) in Greece in 2005 to that in 2008?
Ensure brevity in your answer.  0.6. What is the ratio of the Electricity production(% of total) of Nicaragua in 2005 to that in 2008?
Give a very brief answer. 1.04. What is the ratio of the Electricity production(% of total) in Australia in 2005 to that in 2009?
Offer a terse response. 0.77. What is the ratio of the Electricity production(% of total) of Eritrea in 2005 to that in 2009?
Offer a terse response. 0.51. What is the ratio of the Electricity production(% of total) in Greece in 2005 to that in 2009?
Provide a succinct answer. 0.51. What is the ratio of the Electricity production(% of total) of Nicaragua in 2005 to that in 2009?
Make the answer very short. 0.92. What is the ratio of the Electricity production(% of total) of Australia in 2005 to that in 2010?
Give a very brief answer. 0.65. What is the ratio of the Electricity production(% of total) in Eritrea in 2005 to that in 2010?
Your response must be concise. 0.54. What is the ratio of the Electricity production(% of total) in Greece in 2005 to that in 2010?
Your response must be concise. 0.44. What is the ratio of the Electricity production(% of total) in Nicaragua in 2005 to that in 2010?
Make the answer very short. 0.88. What is the ratio of the Electricity production(% of total) of Australia in 2005 to that in 2011?
Provide a succinct answer. 0.6. What is the ratio of the Electricity production(% of total) in Eritrea in 2005 to that in 2011?
Provide a short and direct response. 0.59. What is the ratio of the Electricity production(% of total) of Greece in 2005 to that in 2011?
Keep it short and to the point. 0.33. What is the ratio of the Electricity production(% of total) of Nicaragua in 2005 to that in 2011?
Offer a very short reply. 0.91. What is the ratio of the Electricity production(% of total) in Australia in 2006 to that in 2007?
Make the answer very short. 0.89. What is the ratio of the Electricity production(% of total) of Eritrea in 2006 to that in 2007?
Offer a very short reply. 1.07. What is the ratio of the Electricity production(% of total) in Greece in 2006 to that in 2007?
Make the answer very short. 0.94. What is the ratio of the Electricity production(% of total) in Australia in 2006 to that in 2008?
Ensure brevity in your answer.  0.76. What is the ratio of the Electricity production(% of total) in Eritrea in 2006 to that in 2008?
Give a very brief answer. 1.07. What is the ratio of the Electricity production(% of total) in Greece in 2006 to that in 2008?
Your response must be concise. 0.78. What is the ratio of the Electricity production(% of total) in Nicaragua in 2006 to that in 2008?
Your answer should be very brief. 1.03. What is the ratio of the Electricity production(% of total) in Australia in 2006 to that in 2009?
Your answer should be very brief. 0.9. What is the ratio of the Electricity production(% of total) in Eritrea in 2006 to that in 2009?
Make the answer very short. 1.1. What is the ratio of the Electricity production(% of total) in Greece in 2006 to that in 2009?
Offer a very short reply. 0.66. What is the ratio of the Electricity production(% of total) of Nicaragua in 2006 to that in 2009?
Make the answer very short. 0.91. What is the ratio of the Electricity production(% of total) in Australia in 2006 to that in 2010?
Your answer should be very brief. 0.76. What is the ratio of the Electricity production(% of total) of Eritrea in 2006 to that in 2010?
Offer a terse response. 1.16. What is the ratio of the Electricity production(% of total) in Greece in 2006 to that in 2010?
Ensure brevity in your answer.  0.56. What is the ratio of the Electricity production(% of total) in Nicaragua in 2006 to that in 2010?
Give a very brief answer. 0.87. What is the ratio of the Electricity production(% of total) of Australia in 2006 to that in 2011?
Your response must be concise. 0.71. What is the ratio of the Electricity production(% of total) in Eritrea in 2006 to that in 2011?
Ensure brevity in your answer.  1.25. What is the ratio of the Electricity production(% of total) in Greece in 2006 to that in 2011?
Keep it short and to the point. 0.43. What is the ratio of the Electricity production(% of total) of Nicaragua in 2006 to that in 2011?
Make the answer very short. 0.9. What is the ratio of the Electricity production(% of total) of Australia in 2007 to that in 2008?
Make the answer very short. 0.85. What is the ratio of the Electricity production(% of total) of Greece in 2007 to that in 2008?
Keep it short and to the point. 0.82. What is the ratio of the Electricity production(% of total) in Nicaragua in 2007 to that in 2008?
Provide a succinct answer. 0.99. What is the ratio of the Electricity production(% of total) of Eritrea in 2007 to that in 2009?
Give a very brief answer. 1.02. What is the ratio of the Electricity production(% of total) of Greece in 2007 to that in 2009?
Make the answer very short. 0.69. What is the ratio of the Electricity production(% of total) in Nicaragua in 2007 to that in 2009?
Provide a succinct answer. 0.87. What is the ratio of the Electricity production(% of total) in Australia in 2007 to that in 2010?
Provide a short and direct response. 0.85. What is the ratio of the Electricity production(% of total) of Eritrea in 2007 to that in 2010?
Make the answer very short. 1.08. What is the ratio of the Electricity production(% of total) of Greece in 2007 to that in 2010?
Make the answer very short. 0.6. What is the ratio of the Electricity production(% of total) in Nicaragua in 2007 to that in 2010?
Offer a very short reply. 0.84. What is the ratio of the Electricity production(% of total) in Australia in 2007 to that in 2011?
Provide a succinct answer. 0.79. What is the ratio of the Electricity production(% of total) in Eritrea in 2007 to that in 2011?
Provide a short and direct response. 1.17. What is the ratio of the Electricity production(% of total) in Greece in 2007 to that in 2011?
Keep it short and to the point. 0.46. What is the ratio of the Electricity production(% of total) in Nicaragua in 2007 to that in 2011?
Offer a very short reply. 0.87. What is the ratio of the Electricity production(% of total) in Australia in 2008 to that in 2009?
Your answer should be very brief. 1.18. What is the ratio of the Electricity production(% of total) of Eritrea in 2008 to that in 2009?
Offer a very short reply. 1.03. What is the ratio of the Electricity production(% of total) in Greece in 2008 to that in 2009?
Your answer should be compact. 0.84. What is the ratio of the Electricity production(% of total) in Nicaragua in 2008 to that in 2009?
Keep it short and to the point. 0.88. What is the ratio of the Electricity production(% of total) of Australia in 2008 to that in 2010?
Keep it short and to the point. 1. What is the ratio of the Electricity production(% of total) in Eritrea in 2008 to that in 2010?
Keep it short and to the point. 1.08. What is the ratio of the Electricity production(% of total) of Greece in 2008 to that in 2010?
Ensure brevity in your answer.  0.73. What is the ratio of the Electricity production(% of total) of Nicaragua in 2008 to that in 2010?
Offer a very short reply. 0.85. What is the ratio of the Electricity production(% of total) in Australia in 2008 to that in 2011?
Give a very brief answer. 0.93. What is the ratio of the Electricity production(% of total) of Eritrea in 2008 to that in 2011?
Your answer should be very brief. 1.17. What is the ratio of the Electricity production(% of total) of Greece in 2008 to that in 2011?
Provide a succinct answer. 0.56. What is the ratio of the Electricity production(% of total) of Nicaragua in 2008 to that in 2011?
Keep it short and to the point. 0.88. What is the ratio of the Electricity production(% of total) of Australia in 2009 to that in 2010?
Offer a terse response. 0.85. What is the ratio of the Electricity production(% of total) in Eritrea in 2009 to that in 2010?
Offer a very short reply. 1.05. What is the ratio of the Electricity production(% of total) of Greece in 2009 to that in 2010?
Offer a terse response. 0.86. What is the ratio of the Electricity production(% of total) of Nicaragua in 2009 to that in 2010?
Your answer should be compact. 0.96. What is the ratio of the Electricity production(% of total) of Australia in 2009 to that in 2011?
Your answer should be compact. 0.79. What is the ratio of the Electricity production(% of total) in Eritrea in 2009 to that in 2011?
Make the answer very short. 1.14. What is the ratio of the Electricity production(% of total) of Greece in 2009 to that in 2011?
Ensure brevity in your answer.  0.66. What is the ratio of the Electricity production(% of total) of Australia in 2010 to that in 2011?
Your answer should be compact. 0.93. What is the ratio of the Electricity production(% of total) of Eritrea in 2010 to that in 2011?
Give a very brief answer. 1.08. What is the ratio of the Electricity production(% of total) in Greece in 2010 to that in 2011?
Provide a short and direct response. 0.76. What is the ratio of the Electricity production(% of total) of Nicaragua in 2010 to that in 2011?
Your answer should be very brief. 1.04. What is the difference between the highest and the second highest Electricity production(% of total) of Australia?
Offer a very short reply. 0.25. What is the difference between the highest and the second highest Electricity production(% of total) of Eritrea?
Your answer should be very brief. 0.05. What is the difference between the highest and the second highest Electricity production(% of total) of Greece?
Your answer should be very brief. 1.65. What is the difference between the highest and the second highest Electricity production(% of total) in Nicaragua?
Ensure brevity in your answer.  0.85. What is the difference between the highest and the lowest Electricity production(% of total) of Australia?
Give a very brief answer. 2.35. What is the difference between the highest and the lowest Electricity production(% of total) in Eritrea?
Provide a succinct answer. 0.4. What is the difference between the highest and the lowest Electricity production(% of total) of Greece?
Your answer should be very brief. 4.86. What is the difference between the highest and the lowest Electricity production(% of total) of Nicaragua?
Offer a terse response. 6.5. 